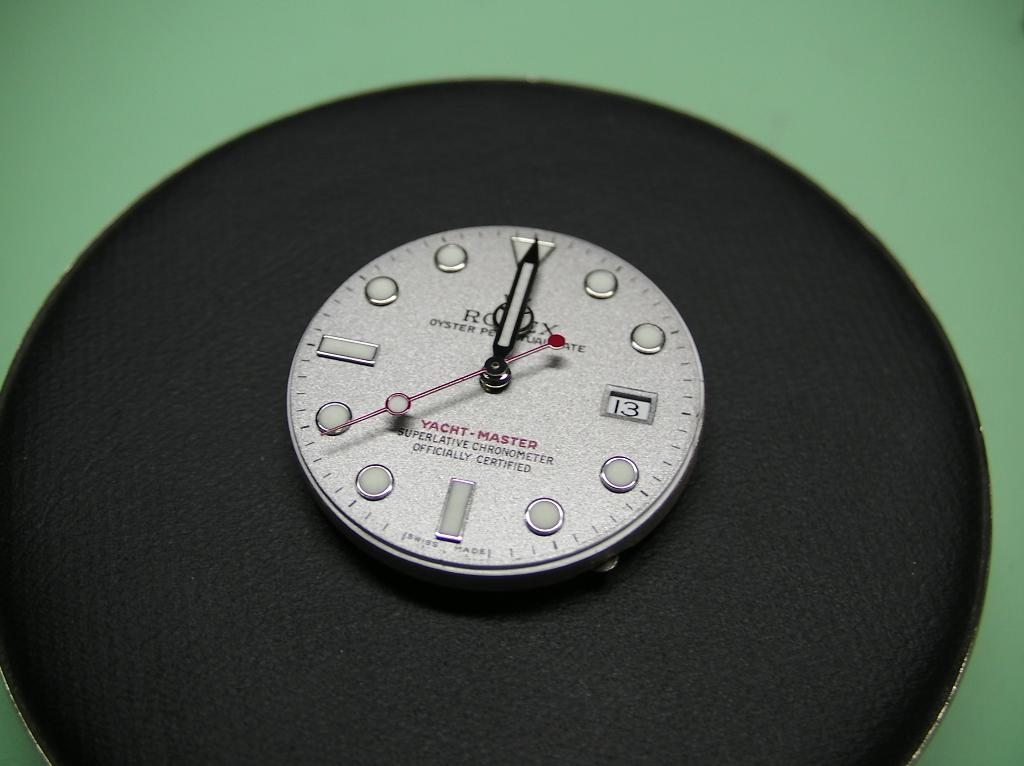<image>
Create a compact narrative representing the image presented. a clock that has the number 13 on it 